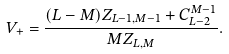<formula> <loc_0><loc_0><loc_500><loc_500>V _ { + } = \frac { ( L - M ) Z _ { L - 1 , M - 1 } + C _ { L - 2 } ^ { M - 1 } } { M Z _ { L , M } } .</formula> 